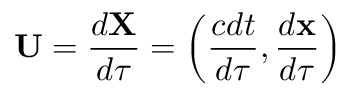<formula> <loc_0><loc_0><loc_500><loc_500>{ U } = { \frac { d { X } } { d \tau } } = \left ( { \frac { c d t } { d \tau } } , { \frac { d x } { d \tau } } \right )</formula> 